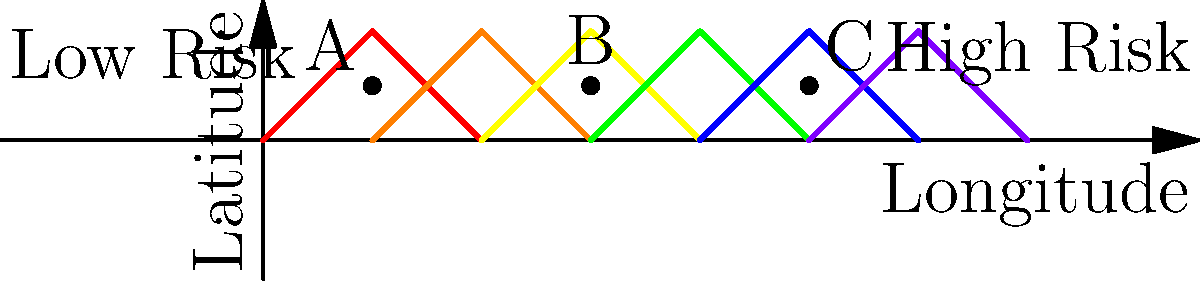Based on the seismic hazard map provided, which of the three potential site options (A, B, or C) would you recommend for the new shopping mall to minimize earthquake risk? To evaluate the earthquake risk for different site options, we need to analyze the seismic hazard map:

1. Understand the map:
   - The x-axis represents longitude, and the y-axis represents latitude.
   - The color gradient from left to right indicates increasing seismic hazard.
   - Red/orange areas represent high risk, while blue/purple areas represent low risk.

2. Locate the site options:
   - Site A is positioned on the left side of the map (blue/purple area).
   - Site B is located in the middle of the map (yellow/green area).
   - Site C is situated on the right side of the map (red/orange area).

3. Assess the risk for each site:
   - Site A: Located in the lowest risk area (blue/purple).
   - Site B: Positioned in a moderate risk area (yellow/green).
   - Site C: Situated in the highest risk area (red/orange).

4. Consider the implications:
   - Building in a high-risk area (Site C) would require more extensive and costly earthquake-resistant design and construction.
   - A moderate-risk area (Site B) would still need significant seismic considerations.
   - A low-risk area (Site A) would require the least amount of additional seismic protection measures.

5. Make a recommendation:
   - Site A presents the lowest seismic hazard and would be the most suitable option for minimizing earthquake risk for the new shopping mall.

Therefore, based on the seismic hazard map, Site A is the recommended option for the new shopping mall to minimize earthquake risk.
Answer: Site A 